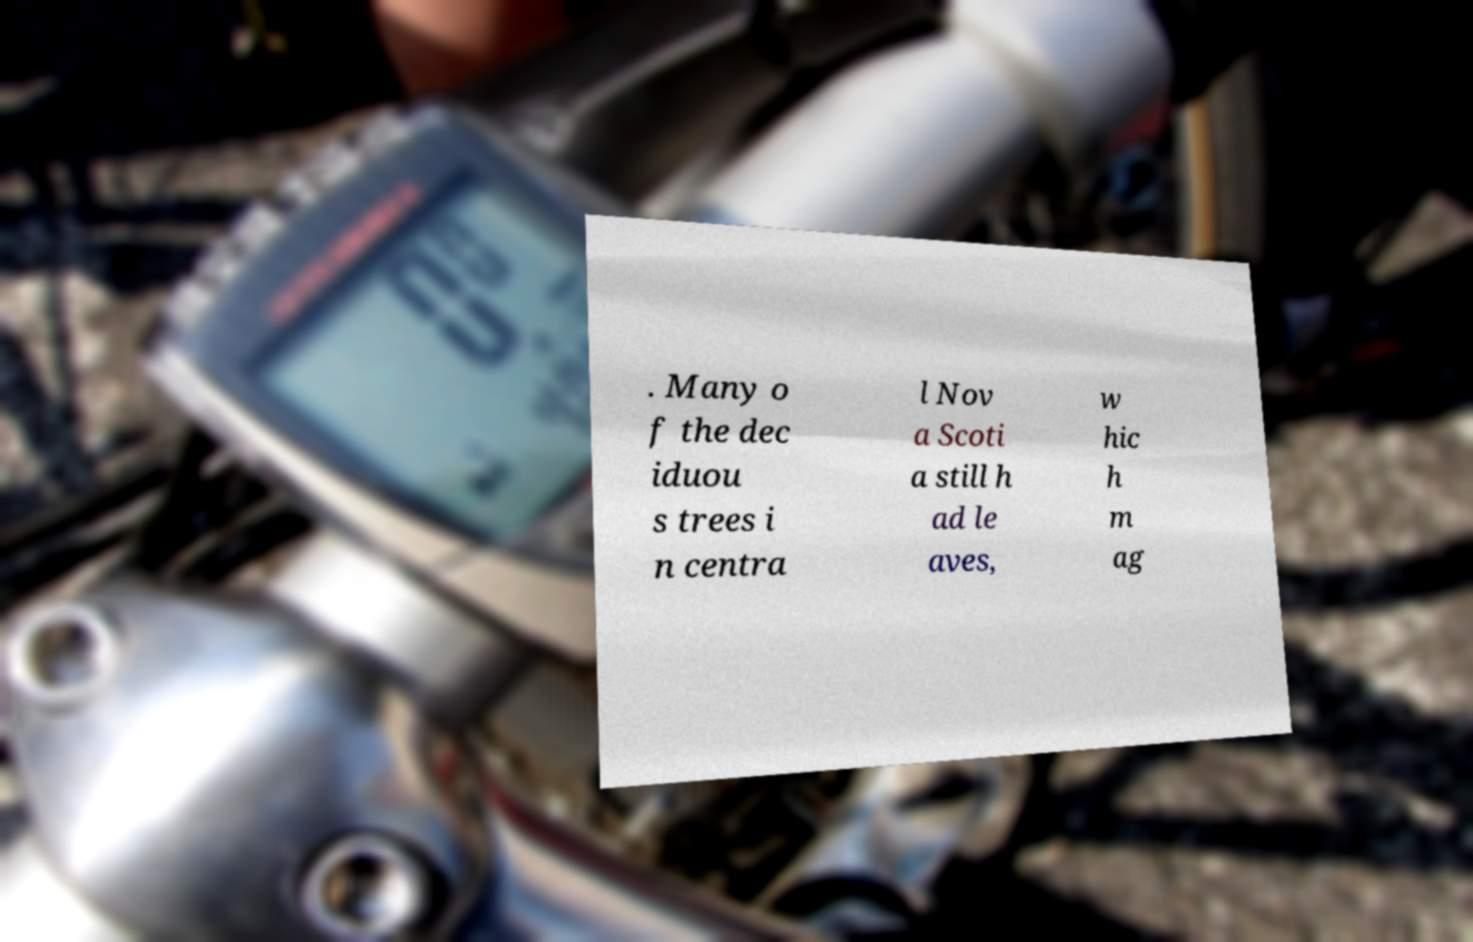Could you assist in decoding the text presented in this image and type it out clearly? . Many o f the dec iduou s trees i n centra l Nov a Scoti a still h ad le aves, w hic h m ag 